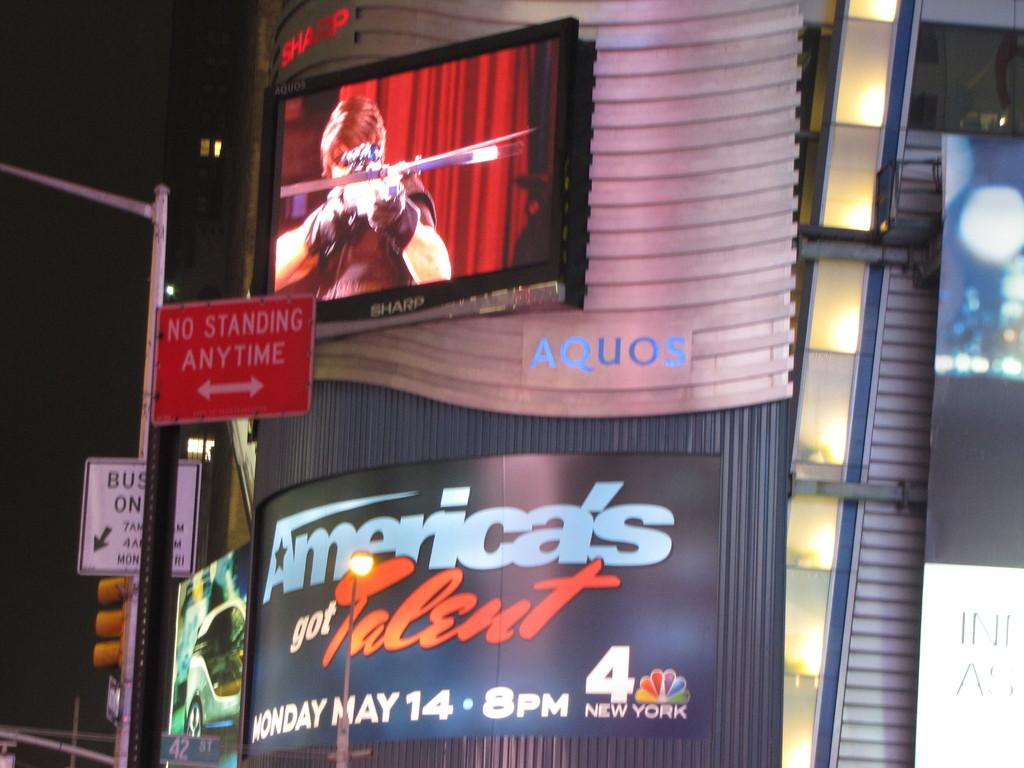<image>
Provide a brief description of the given image. a red no standing anytime sign in front of an aquos display showing ad for america's got talent 